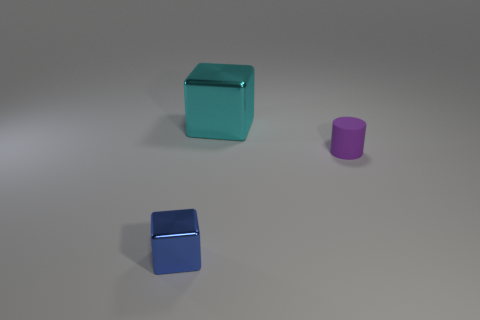What is the size of the other block that is the same material as the large cube?
Offer a very short reply. Small. There is a object that is on the right side of the metallic object that is behind the small blue object; are there any large cyan objects that are on the right side of it?
Make the answer very short. No. There is a blue metallic cube left of the purple matte thing; is its size the same as the big cyan object?
Offer a very short reply. No. How many things are the same size as the purple cylinder?
Offer a terse response. 1. The small purple thing has what shape?
Make the answer very short. Cylinder. Is the number of things left of the tiny purple matte thing greater than the number of big shiny cubes?
Give a very brief answer. Yes. There is a cyan thing; is it the same shape as the object that is to the left of the large cyan object?
Give a very brief answer. Yes. Is there a large yellow metallic object?
Provide a succinct answer. No. How many large objects are either purple things or blue spheres?
Your answer should be compact. 0. Is the number of cubes right of the small blue shiny block greater than the number of purple rubber cylinders that are behind the cyan thing?
Give a very brief answer. Yes. 